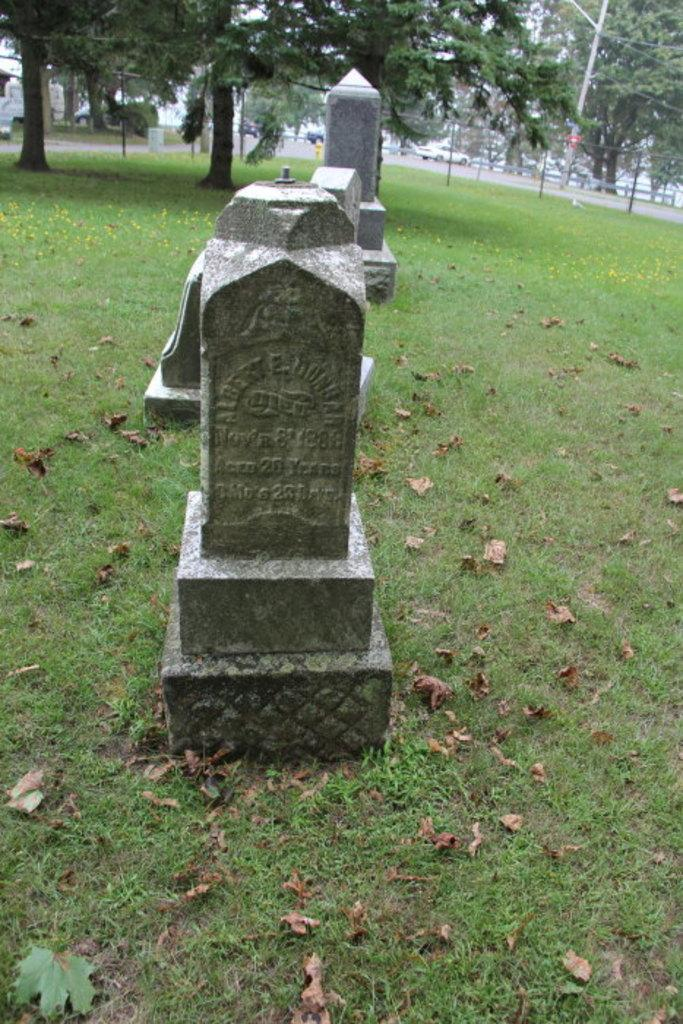What type of ground surface is shown in the image? There are laid stones on the ground in the image. What can be seen scattered on the ground? Shredded leaves are visible in the image. What type of vegetation is present in the image? There are present in the image. What structures are visible in the image? Poles are present in the image. What type of transportation is visible in the image? Motor vehicles are visible in the image. What hobbies are the trees participating in within the image? Trees do not participate in hobbies, as they are inanimate objects. 